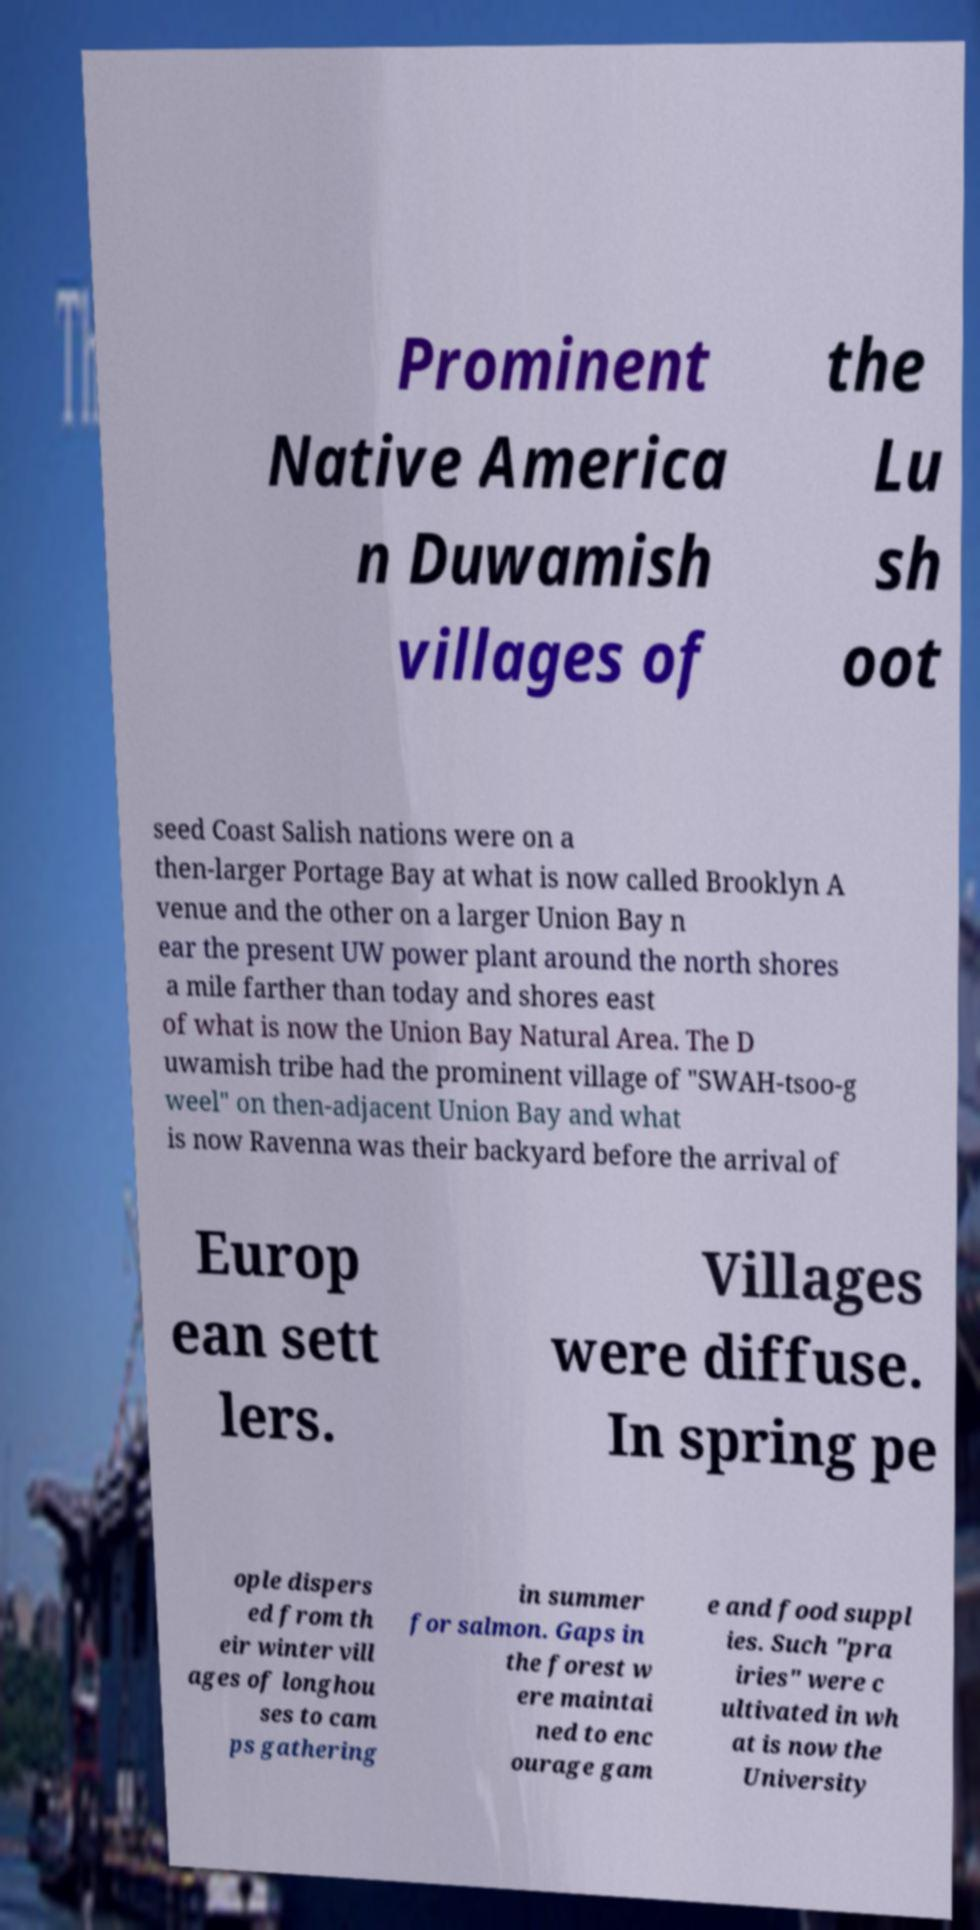Can you read and provide the text displayed in the image?This photo seems to have some interesting text. Can you extract and type it out for me? Prominent Native America n Duwamish villages of the Lu sh oot seed Coast Salish nations were on a then-larger Portage Bay at what is now called Brooklyn A venue and the other on a larger Union Bay n ear the present UW power plant around the north shores a mile farther than today and shores east of what is now the Union Bay Natural Area. The D uwamish tribe had the prominent village of "SWAH-tsoo-g weel" on then-adjacent Union Bay and what is now Ravenna was their backyard before the arrival of Europ ean sett lers. Villages were diffuse. In spring pe ople dispers ed from th eir winter vill ages of longhou ses to cam ps gathering in summer for salmon. Gaps in the forest w ere maintai ned to enc ourage gam e and food suppl ies. Such "pra iries" were c ultivated in wh at is now the University 